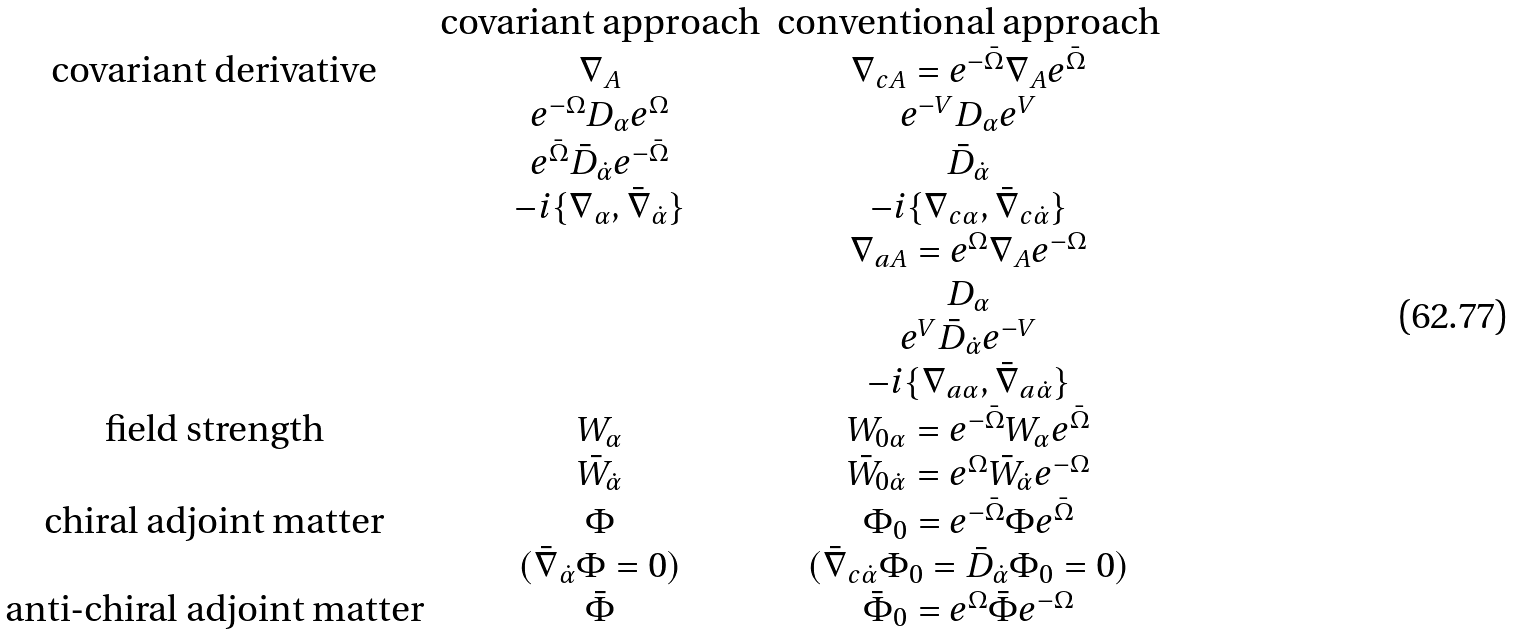<formula> <loc_0><loc_0><loc_500><loc_500>\begin{array} { c c c } & \text {covariant approach} & \text {conventional approach} \\ \text {covariant derivative} & \nabla _ { A } & \nabla _ { c A } = e ^ { - \bar { \Omega } } \nabla _ { A } e ^ { \bar { \Omega } } \\ & e ^ { - \Omega } D _ { \alpha } e ^ { \Omega } & e ^ { - V } D _ { \alpha } e ^ { V } \\ & e ^ { \bar { \Omega } } \bar { D } _ { \dot { \alpha } } e ^ { - \bar { \Omega } } & \bar { D } _ { \dot { \alpha } } \\ & - i \{ \nabla _ { \alpha } , \bar { \nabla } _ { \dot { \alpha } } \} & - i \{ \nabla _ { c \alpha } , \bar { \nabla } _ { c \dot { \alpha } } \} \\ & & \nabla _ { a A } = e ^ { \Omega } \nabla _ { A } e ^ { - \Omega } \\ & & D _ { \alpha } \\ & & e ^ { V } \bar { D } _ { \dot { \alpha } } e ^ { - V } \\ & & - i \{ \nabla _ { a \alpha } , \bar { \nabla } _ { a \dot { \alpha } } \} \\ \text {field strength} & W _ { \alpha } & W _ { 0 \alpha } = e ^ { - \bar { \Omega } } W _ { \alpha } e ^ { \bar { \Omega } } \\ & \bar { W } _ { \dot { \alpha } } & \bar { W } _ { 0 \dot { \alpha } } = e ^ { \Omega } \bar { W } _ { \dot { \alpha } } e ^ { - \Omega } \\ \text {chiral adjoint matter} & \Phi & \Phi _ { 0 } = e ^ { - \bar { \Omega } } \Phi e ^ { \bar { \Omega } } \\ & ( \bar { \nabla } _ { \dot { \alpha } } \Phi = 0 ) & ( \bar { \nabla } _ { c \dot { \alpha } } \Phi _ { 0 } = \bar { D } _ { \dot { \alpha } } \Phi _ { 0 } = 0 ) \\ \text {anti-chiral adjoint matter} & \bar { \Phi } & \bar { \Phi } _ { 0 } = e ^ { \Omega } \bar { \Phi } e ^ { - \Omega } \end{array}</formula> 